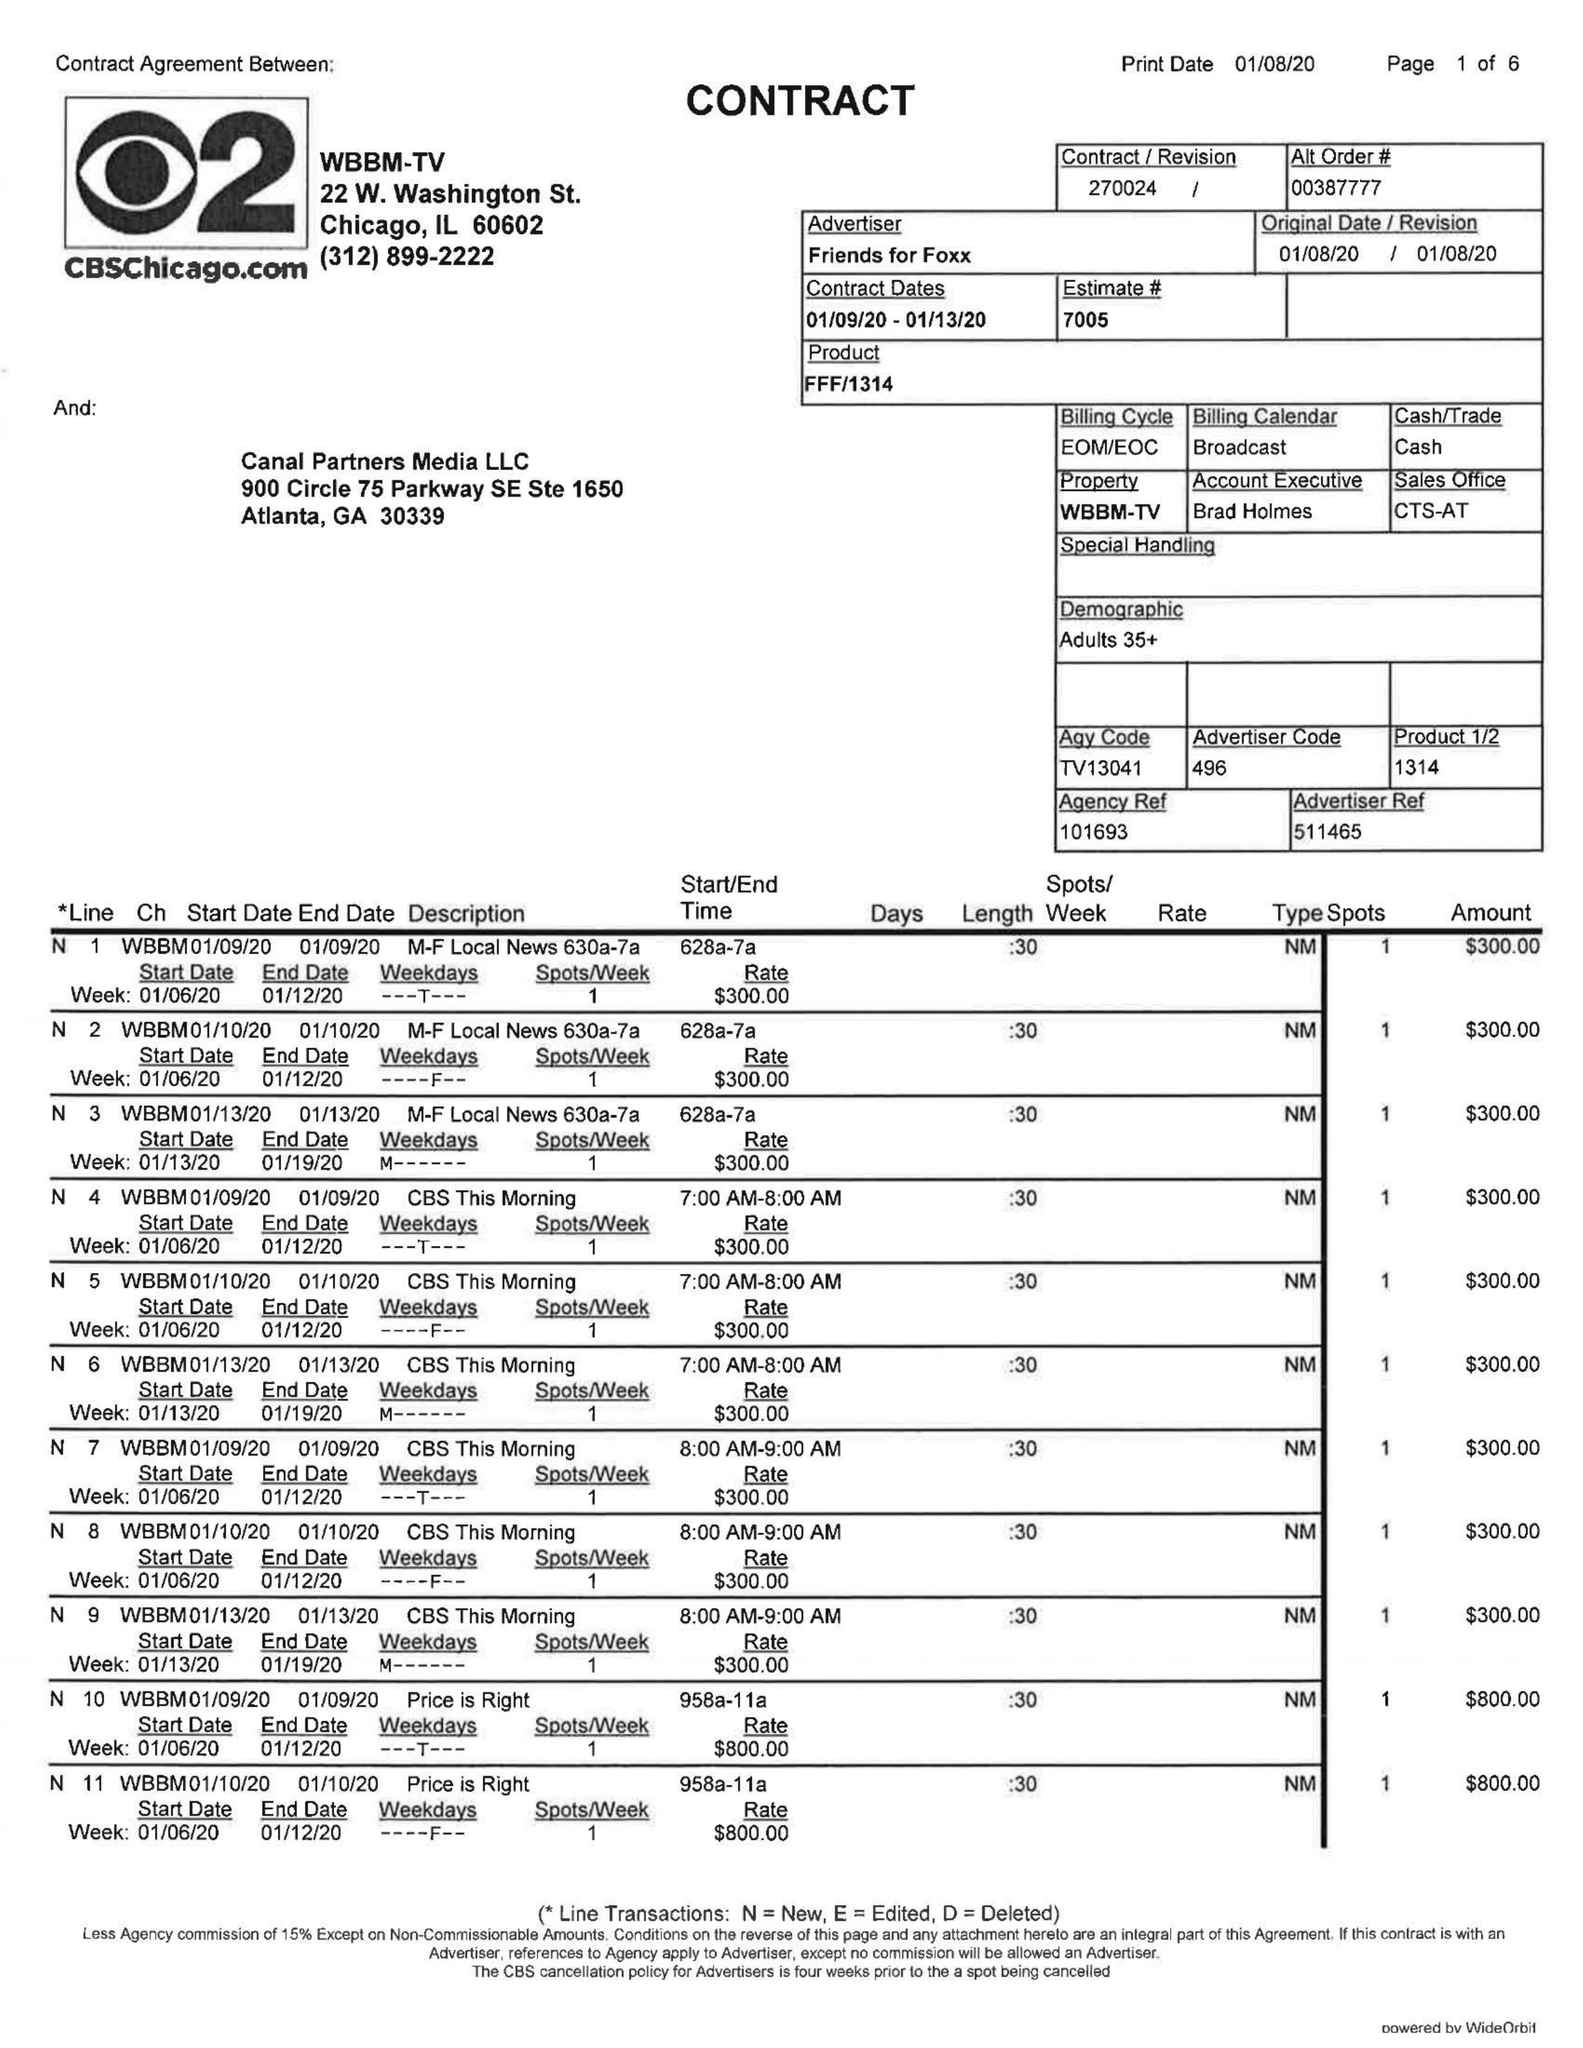What is the value for the flight_from?
Answer the question using a single word or phrase. 01/09/20 